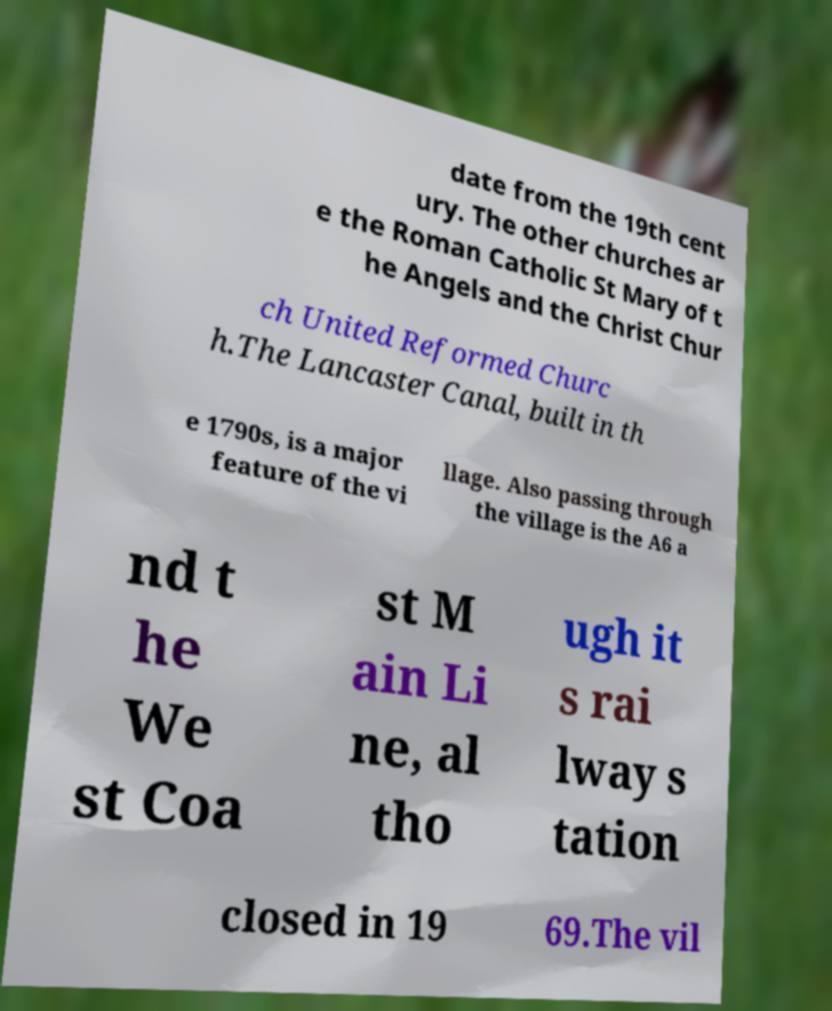Could you assist in decoding the text presented in this image and type it out clearly? date from the 19th cent ury. The other churches ar e the Roman Catholic St Mary of t he Angels and the Christ Chur ch United Reformed Churc h.The Lancaster Canal, built in th e 1790s, is a major feature of the vi llage. Also passing through the village is the A6 a nd t he We st Coa st M ain Li ne, al tho ugh it s rai lway s tation closed in 19 69.The vil 